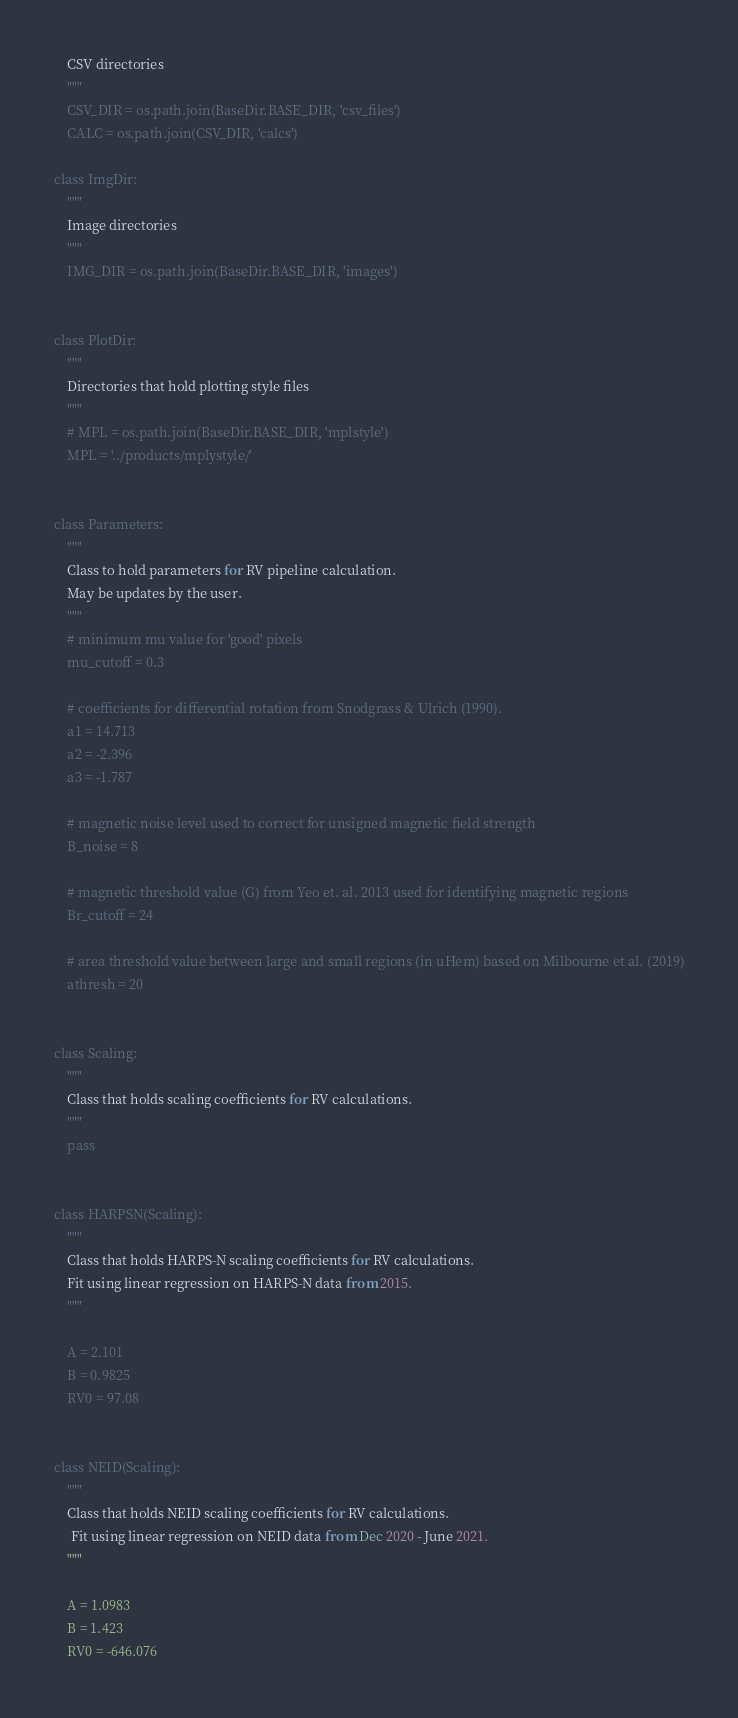<code> <loc_0><loc_0><loc_500><loc_500><_Python_>    CSV directories
    """
    CSV_DIR = os.path.join(BaseDir.BASE_DIR, 'csv_files')
    CALC = os.path.join(CSV_DIR, 'calcs')

class ImgDir:
    """
    Image directories
    """
    IMG_DIR = os.path.join(BaseDir.BASE_DIR, 'images')


class PlotDir:
    """
    Directories that hold plotting style files
    """
    # MPL = os.path.join(BaseDir.BASE_DIR, 'mplstyle')
    MPL = '../products/mplystyle/'


class Parameters:
    """
    Class to hold parameters for RV pipeline calculation.
    May be updates by the user.
    """
    # minimum mu value for 'good' pixels
    mu_cutoff = 0.3

    # coefficients for differential rotation from Snodgrass & Ulrich (1990).
    a1 = 14.713
    a2 = -2.396
    a3 = -1.787

    # magnetic noise level used to correct for unsigned magnetic field strength
    B_noise = 8

    # magnetic threshold value (G) from Yeo et. al. 2013 used for identifying magnetic regions
    Br_cutoff = 24

    # area threshold value between large and small regions (in uHem) based on Milbourne et al. (2019)
    athresh = 20


class Scaling:
    """
    Class that holds scaling coefficients for RV calculations.
    """
    pass


class HARPSN(Scaling):
    """
    Class that holds HARPS-N scaling coefficients for RV calculations.
    Fit using linear regression on HARPS-N data from 2015.
    """

    A = 2.101
    B = 0.9825
    RV0 = 97.08


class NEID(Scaling):
    """
    Class that holds NEID scaling coefficients for RV calculations.
     Fit using linear regression on NEID data from Dec 2020 - June 2021.
    """

    A = 1.0983
    B = 1.423
    RV0 = -646.076

</code> 